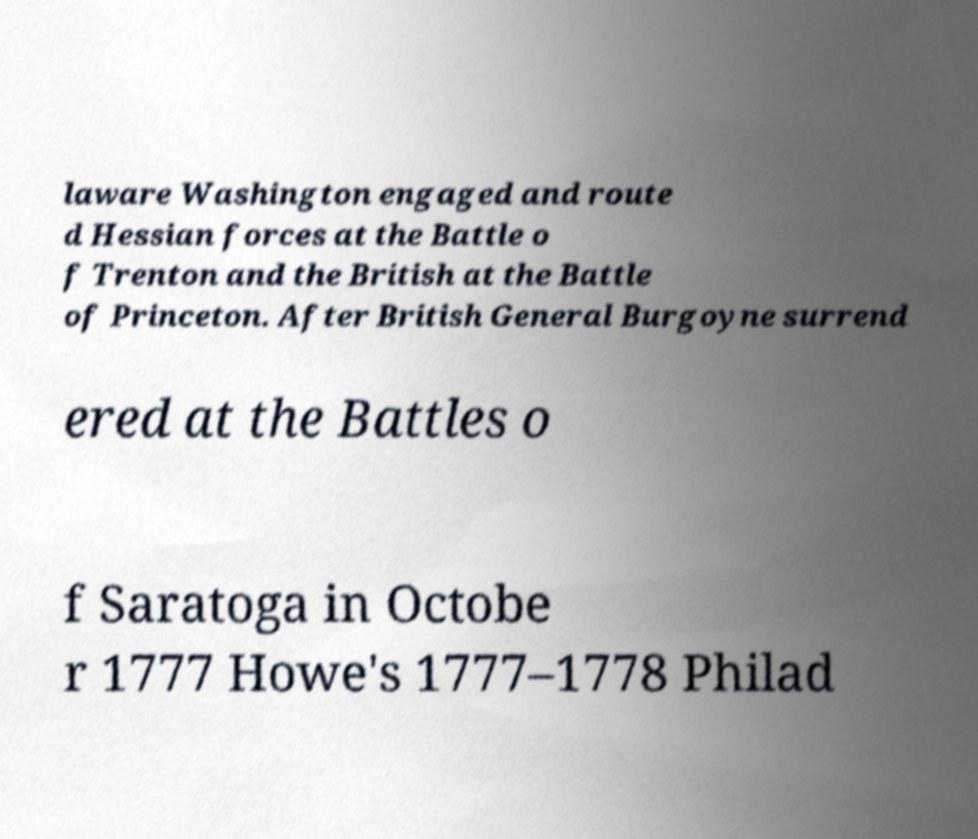Could you assist in decoding the text presented in this image and type it out clearly? laware Washington engaged and route d Hessian forces at the Battle o f Trenton and the British at the Battle of Princeton. After British General Burgoyne surrend ered at the Battles o f Saratoga in Octobe r 1777 Howe's 1777–1778 Philad 